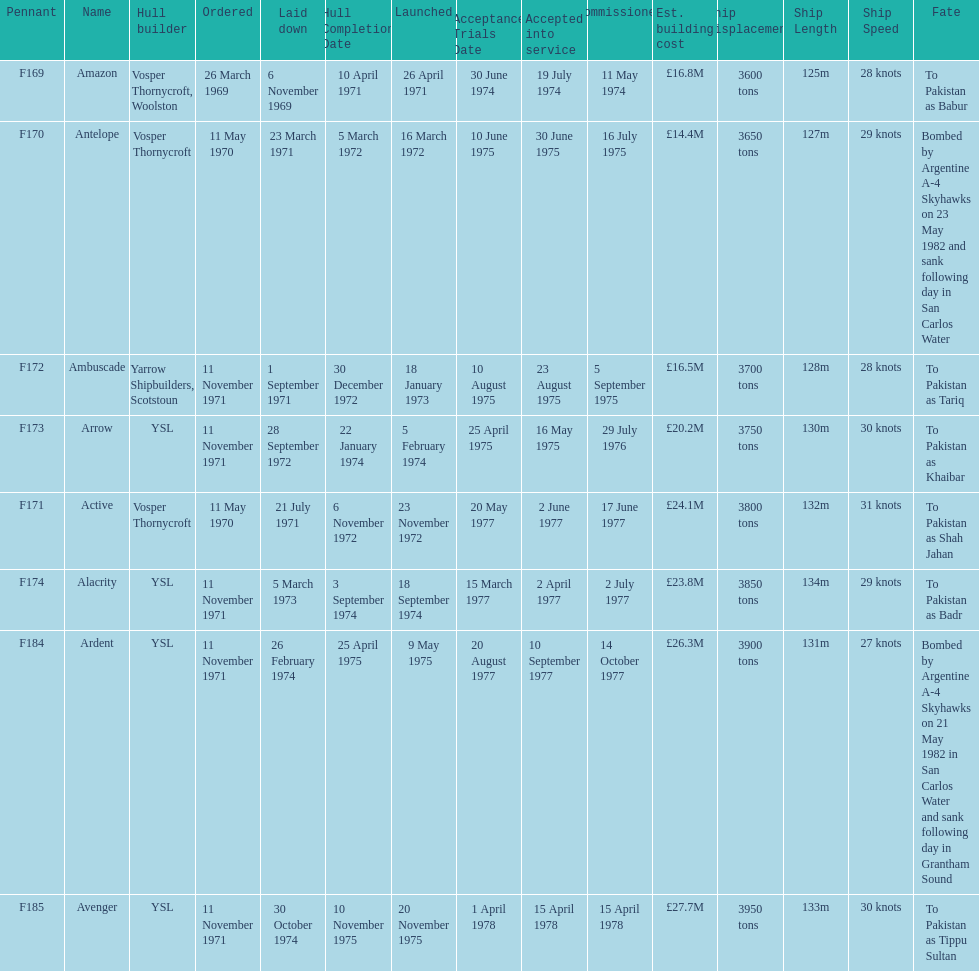How many ships were laid down in september? 2. 